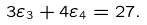<formula> <loc_0><loc_0><loc_500><loc_500>3 \varepsilon _ { 3 } + 4 \varepsilon _ { 4 } = 2 7 .</formula> 